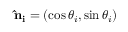<formula> <loc_0><loc_0><loc_500><loc_500>\hat { n } _ { i } = ( \cos \theta _ { i } , \sin \theta _ { i } )</formula> 